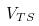Convert formula to latex. <formula><loc_0><loc_0><loc_500><loc_500>V _ { T S }</formula> 